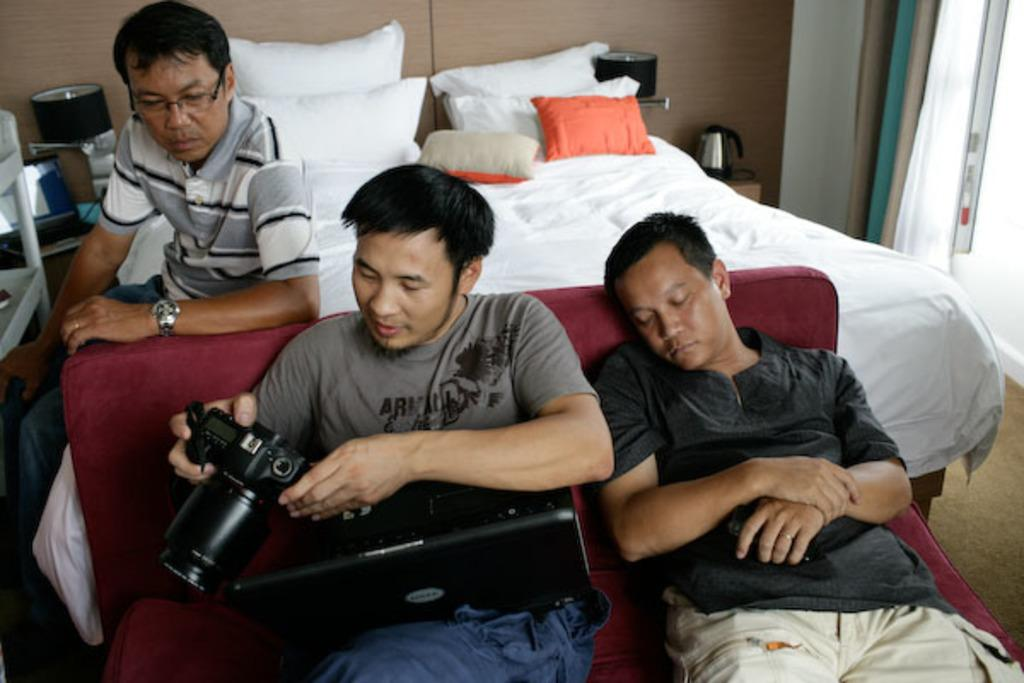How many people are visible in the image? There are three people in the image. Where are the people located? Two people are on a sofa, and another person is on a bed. Can you describe the seating arrangement of the people on the sofa? The facts do not specify the seating arrangement of the people on the sofa. How does the cow balance itself on the bed in the image? There is no cow present in the image; it only features two people on a sofa and another person on a bed. 